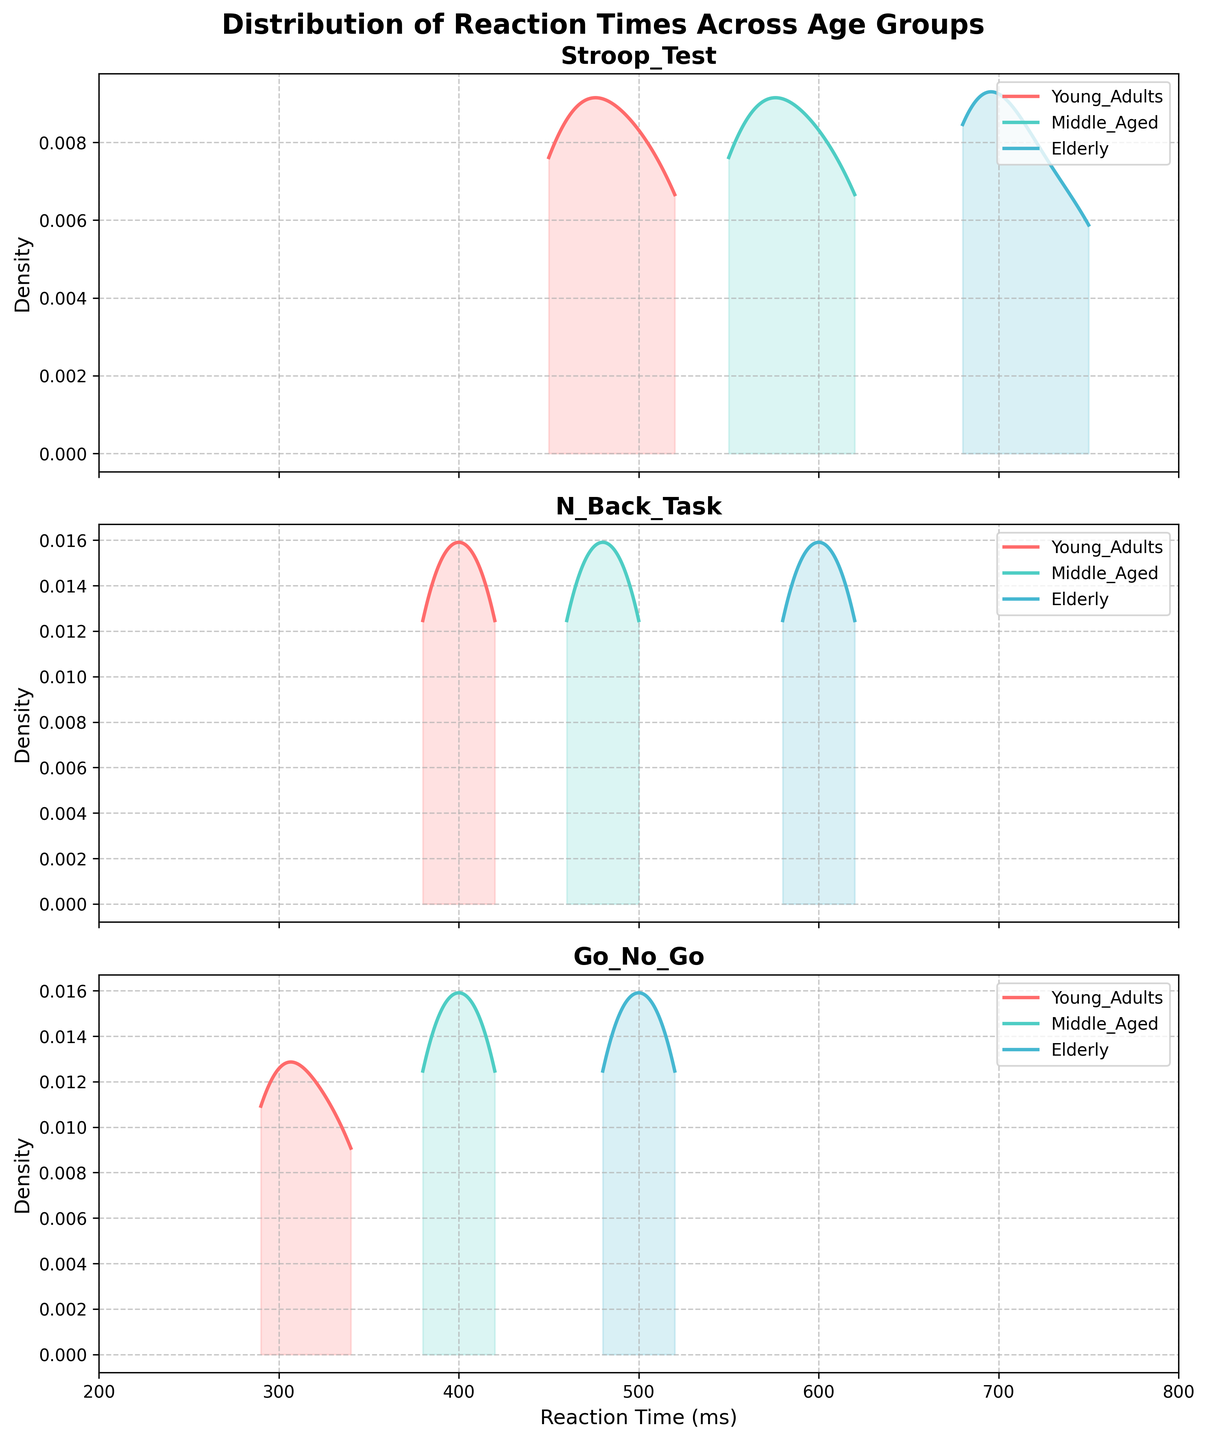What is the title of the figure? The title is located at the top center of the figure, and it reads "Distribution of Reaction Times Across Age Groups".
Answer: Distribution of Reaction Times Across Age Groups How many subplots are there in the figure? By visually inspecting the figure, it's clear there are three distinct subplots, each representing a different type of cognitive task.
Answer: Three Which cognitive task has the highest reaction times for the Elderly group? Looking at the highest value in the density plots for the Elderly group, we can see that the Stroop Test has the highest reaction times.
Answer: Stroop Test Which age group generally shows the fastest reaction times in the N-Back Task? By comparing the peaks of the density plots for each age group in the N-Back Task subplot, we see the Young Adults group has the highest peak at the lowest reaction times.
Answer: Young Adults What is the range of reaction times covered in the x-axis of the subplots? The x-axis range is marked from 200 ms to 800 ms across all subplots, covering the range of reaction times measured.
Answer: 200 ms to 800 ms Which task shows the smallest difference in reaction times between Young Adults and Middle Aged groups? We compare the density plots for Young Adults and Middle Aged groups across all tasks. The Go/No-Go task has minimal difference in reaction time density peaks between these groups.
Answer: Go/No-Go Does the reaction time distribution for the Go/No-Go task show a higher overall density for Middle Aged compared to Elderly? By examining the density plot for the Go/No-Go task, the density is higher for the Middle Aged group across the majority of the reaction time range compared to the Elderly group.
Answer: Yes How does the peak reaction time for the Stroop Test in Elderly group compare to the Middle Aged group? The peak reaction time for the Elderly group in the Stroop Test is higher than that of the Middle Aged group as shown by the density plots.
Answer: Higher In the N-Back Task, which age group shows the most spread in reaction times? By inspecting the width of the density plot, the Elderly group shows the most spread indicating more variability in their reaction times.
Answer: Elderly In which cognitive task is the difference in reaction times between Young Adults and Elderly most significant? By visually inspecting the density plots for all tasks, the Stroop Test shows the most significant difference with Young Adults having much faster reaction times than the Elderly.
Answer: Stroop Test 